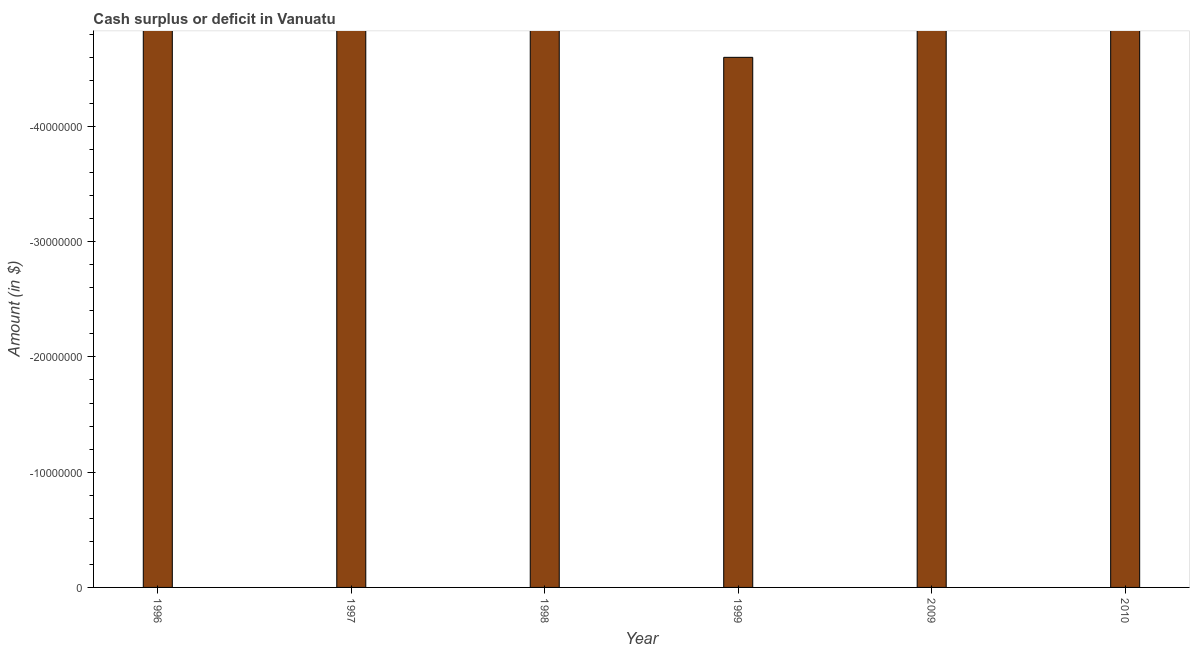What is the title of the graph?
Give a very brief answer. Cash surplus or deficit in Vanuatu. What is the label or title of the X-axis?
Make the answer very short. Year. What is the label or title of the Y-axis?
Give a very brief answer. Amount (in $). What is the cash surplus or deficit in 1998?
Keep it short and to the point. 0. Across all years, what is the minimum cash surplus or deficit?
Keep it short and to the point. 0. In how many years, is the cash surplus or deficit greater than -32000000 $?
Offer a terse response. 0. In how many years, is the cash surplus or deficit greater than the average cash surplus or deficit taken over all years?
Give a very brief answer. 0. Are all the bars in the graph horizontal?
Keep it short and to the point. No. What is the Amount (in $) of 1996?
Give a very brief answer. 0. What is the Amount (in $) of 1998?
Make the answer very short. 0. What is the Amount (in $) in 1999?
Your answer should be very brief. 0. What is the Amount (in $) of 2010?
Keep it short and to the point. 0. 